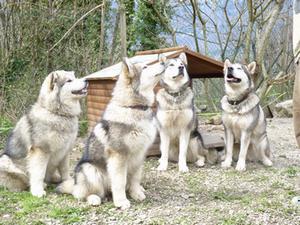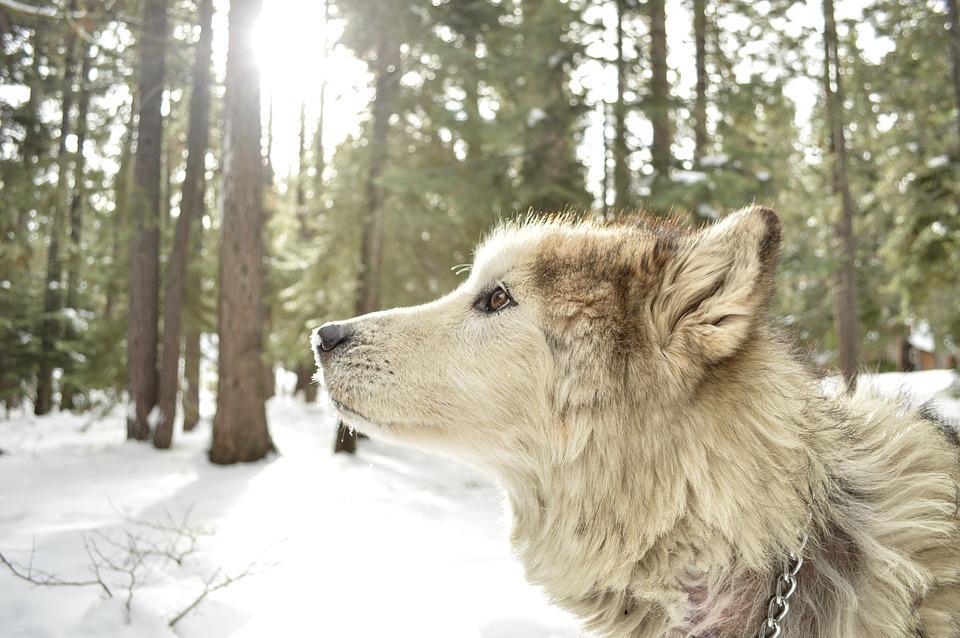The first image is the image on the left, the second image is the image on the right. Evaluate the accuracy of this statement regarding the images: "In the image on the left, four Malamutes are sitting in the grass in front of a shelter and looking up at something.". Is it true? Answer yes or no. Yes. The first image is the image on the left, the second image is the image on the right. Assess this claim about the two images: "In one image, four dogs are sitting in a group, while a single dog is in a second image.". Correct or not? Answer yes or no. Yes. 